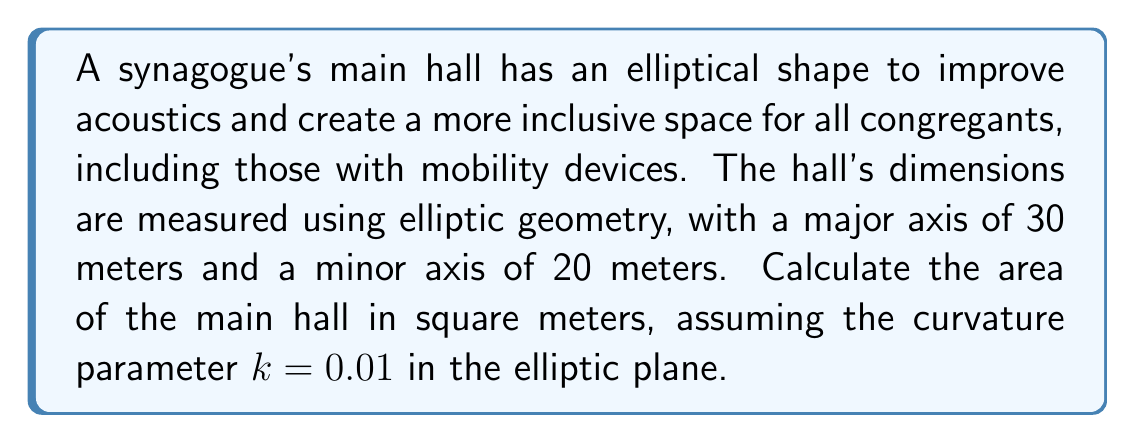Show me your answer to this math problem. To calculate the area of the elliptical main hall using elliptic geometry, we'll follow these steps:

1) In elliptic geometry, the area of an ellipse is given by the formula:

   $$A = \frac{4\pi ab}{4 + k(a^2 + b^2)}$$

   where $a$ is the semi-major axis, $b$ is the semi-minor axis, and $k$ is the curvature parameter.

2) We're given:
   - Major axis = 30 m, so $a = 15$ m
   - Minor axis = 20 m, so $b = 10$ m
   - $k = 0.01$

3) Let's substitute these values into the formula:

   $$A = \frac{4\pi (15)(10)}{4 + 0.01(15^2 + 10^2)}$$

4) Simplify the numerator:
   $$A = \frac{600\pi}{4 + 0.01(225 + 100)}$$

5) Simplify the denominator:
   $$A = \frac{600\pi}{4 + 0.01(325)} = \frac{600\pi}{4 + 3.25} = \frac{600\pi}{7.25}$$

6) Calculate the final result:
   $$A \approx 259.86 \text{ m}^2$$

This area takes into account the curvature of the elliptic plane, which slightly reduces the area compared to what it would be in Euclidean geometry.
Answer: $259.86 \text{ m}^2$ 